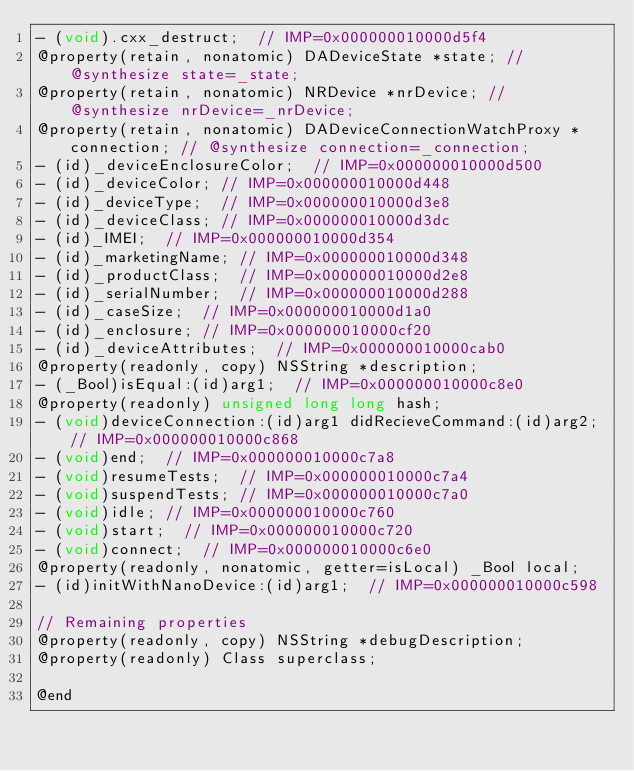<code> <loc_0><loc_0><loc_500><loc_500><_C_>- (void).cxx_destruct;	// IMP=0x000000010000d5f4
@property(retain, nonatomic) DADeviceState *state; // @synthesize state=_state;
@property(retain, nonatomic) NRDevice *nrDevice; // @synthesize nrDevice=_nrDevice;
@property(retain, nonatomic) DADeviceConnectionWatchProxy *connection; // @synthesize connection=_connection;
- (id)_deviceEnclosureColor;	// IMP=0x000000010000d500
- (id)_deviceColor;	// IMP=0x000000010000d448
- (id)_deviceType;	// IMP=0x000000010000d3e8
- (id)_deviceClass;	// IMP=0x000000010000d3dc
- (id)_IMEI;	// IMP=0x000000010000d354
- (id)_marketingName;	// IMP=0x000000010000d348
- (id)_productClass;	// IMP=0x000000010000d2e8
- (id)_serialNumber;	// IMP=0x000000010000d288
- (id)_caseSize;	// IMP=0x000000010000d1a0
- (id)_enclosure;	// IMP=0x000000010000cf20
- (id)_deviceAttributes;	// IMP=0x000000010000cab0
@property(readonly, copy) NSString *description;
- (_Bool)isEqual:(id)arg1;	// IMP=0x000000010000c8e0
@property(readonly) unsigned long long hash;
- (void)deviceConnection:(id)arg1 didRecieveCommand:(id)arg2;	// IMP=0x000000010000c868
- (void)end;	// IMP=0x000000010000c7a8
- (void)resumeTests;	// IMP=0x000000010000c7a4
- (void)suspendTests;	// IMP=0x000000010000c7a0
- (void)idle;	// IMP=0x000000010000c760
- (void)start;	// IMP=0x000000010000c720
- (void)connect;	// IMP=0x000000010000c6e0
@property(readonly, nonatomic, getter=isLocal) _Bool local;
- (id)initWithNanoDevice:(id)arg1;	// IMP=0x000000010000c598

// Remaining properties
@property(readonly, copy) NSString *debugDescription;
@property(readonly) Class superclass;

@end

</code> 